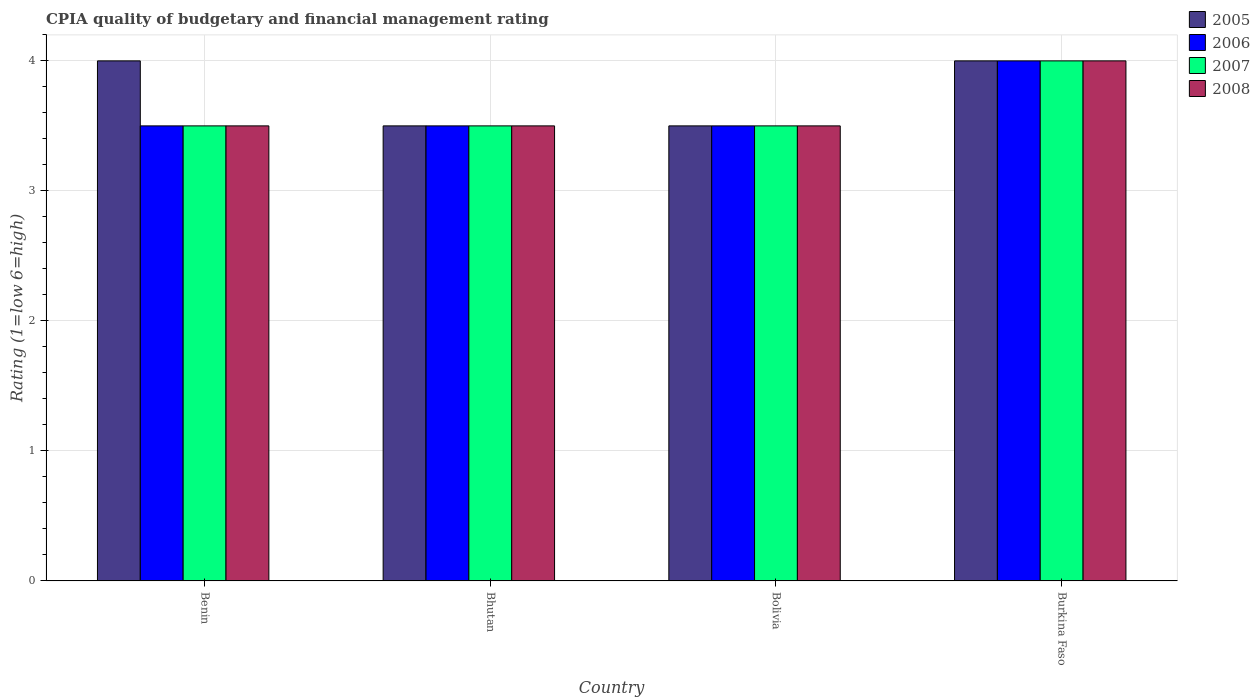How many groups of bars are there?
Offer a very short reply. 4. What is the label of the 2nd group of bars from the left?
Offer a terse response. Bhutan. What is the CPIA rating in 2005 in Bhutan?
Offer a very short reply. 3.5. Across all countries, what is the maximum CPIA rating in 2007?
Ensure brevity in your answer.  4. In which country was the CPIA rating in 2007 maximum?
Give a very brief answer. Burkina Faso. In which country was the CPIA rating in 2007 minimum?
Give a very brief answer. Benin. What is the difference between the CPIA rating in 2008 in Burkina Faso and the CPIA rating in 2005 in Bhutan?
Provide a succinct answer. 0.5. What is the average CPIA rating in 2006 per country?
Give a very brief answer. 3.62. What is the ratio of the CPIA rating in 2006 in Bolivia to that in Burkina Faso?
Your response must be concise. 0.88. Is the CPIA rating in 2007 in Bolivia less than that in Burkina Faso?
Keep it short and to the point. Yes. In how many countries, is the CPIA rating in 2007 greater than the average CPIA rating in 2007 taken over all countries?
Your answer should be compact. 1. What does the 3rd bar from the left in Benin represents?
Offer a terse response. 2007. Is it the case that in every country, the sum of the CPIA rating in 2007 and CPIA rating in 2008 is greater than the CPIA rating in 2005?
Provide a short and direct response. Yes. How many countries are there in the graph?
Make the answer very short. 4. What is the difference between two consecutive major ticks on the Y-axis?
Offer a very short reply. 1. Does the graph contain any zero values?
Your response must be concise. No. Where does the legend appear in the graph?
Ensure brevity in your answer.  Top right. How are the legend labels stacked?
Give a very brief answer. Vertical. What is the title of the graph?
Offer a terse response. CPIA quality of budgetary and financial management rating. What is the label or title of the Y-axis?
Your response must be concise. Rating (1=low 6=high). What is the Rating (1=low 6=high) of 2005 in Benin?
Provide a succinct answer. 4. What is the Rating (1=low 6=high) in 2007 in Benin?
Ensure brevity in your answer.  3.5. What is the Rating (1=low 6=high) in 2005 in Bhutan?
Provide a succinct answer. 3.5. What is the Rating (1=low 6=high) in 2006 in Bhutan?
Provide a succinct answer. 3.5. What is the Rating (1=low 6=high) of 2008 in Bhutan?
Provide a succinct answer. 3.5. What is the Rating (1=low 6=high) of 2005 in Bolivia?
Your answer should be compact. 3.5. What is the Rating (1=low 6=high) of 2006 in Bolivia?
Provide a succinct answer. 3.5. What is the Rating (1=low 6=high) of 2007 in Bolivia?
Provide a succinct answer. 3.5. What is the Rating (1=low 6=high) of 2008 in Bolivia?
Provide a short and direct response. 3.5. What is the Rating (1=low 6=high) of 2005 in Burkina Faso?
Give a very brief answer. 4. What is the Rating (1=low 6=high) in 2006 in Burkina Faso?
Your answer should be very brief. 4. What is the Rating (1=low 6=high) in 2007 in Burkina Faso?
Your answer should be compact. 4. Across all countries, what is the maximum Rating (1=low 6=high) in 2005?
Offer a very short reply. 4. Across all countries, what is the maximum Rating (1=low 6=high) in 2006?
Your answer should be very brief. 4. Across all countries, what is the minimum Rating (1=low 6=high) of 2006?
Offer a terse response. 3.5. Across all countries, what is the minimum Rating (1=low 6=high) of 2008?
Offer a very short reply. 3.5. What is the total Rating (1=low 6=high) of 2007 in the graph?
Your response must be concise. 14.5. What is the difference between the Rating (1=low 6=high) of 2005 in Benin and that in Bhutan?
Give a very brief answer. 0.5. What is the difference between the Rating (1=low 6=high) of 2006 in Benin and that in Bhutan?
Make the answer very short. 0. What is the difference between the Rating (1=low 6=high) of 2007 in Benin and that in Bhutan?
Your answer should be compact. 0. What is the difference between the Rating (1=low 6=high) of 2008 in Benin and that in Bhutan?
Provide a succinct answer. 0. What is the difference between the Rating (1=low 6=high) in 2005 in Benin and that in Bolivia?
Ensure brevity in your answer.  0.5. What is the difference between the Rating (1=low 6=high) in 2007 in Benin and that in Bolivia?
Give a very brief answer. 0. What is the difference between the Rating (1=low 6=high) of 2005 in Benin and that in Burkina Faso?
Offer a terse response. 0. What is the difference between the Rating (1=low 6=high) in 2007 in Benin and that in Burkina Faso?
Your answer should be compact. -0.5. What is the difference between the Rating (1=low 6=high) in 2006 in Bhutan and that in Bolivia?
Provide a short and direct response. 0. What is the difference between the Rating (1=low 6=high) in 2007 in Bhutan and that in Bolivia?
Keep it short and to the point. 0. What is the difference between the Rating (1=low 6=high) of 2007 in Bhutan and that in Burkina Faso?
Make the answer very short. -0.5. What is the difference between the Rating (1=low 6=high) of 2006 in Bolivia and that in Burkina Faso?
Give a very brief answer. -0.5. What is the difference between the Rating (1=low 6=high) of 2005 in Benin and the Rating (1=low 6=high) of 2006 in Bhutan?
Give a very brief answer. 0.5. What is the difference between the Rating (1=low 6=high) in 2005 in Benin and the Rating (1=low 6=high) in 2007 in Bhutan?
Your response must be concise. 0.5. What is the difference between the Rating (1=low 6=high) of 2005 in Benin and the Rating (1=low 6=high) of 2008 in Bhutan?
Make the answer very short. 0.5. What is the difference between the Rating (1=low 6=high) of 2006 in Benin and the Rating (1=low 6=high) of 2007 in Bhutan?
Provide a short and direct response. 0. What is the difference between the Rating (1=low 6=high) in 2005 in Benin and the Rating (1=low 6=high) in 2008 in Bolivia?
Keep it short and to the point. 0.5. What is the difference between the Rating (1=low 6=high) in 2006 in Benin and the Rating (1=low 6=high) in 2008 in Bolivia?
Provide a succinct answer. 0. What is the difference between the Rating (1=low 6=high) of 2007 in Benin and the Rating (1=low 6=high) of 2008 in Bolivia?
Provide a short and direct response. 0. What is the difference between the Rating (1=low 6=high) of 2005 in Benin and the Rating (1=low 6=high) of 2006 in Burkina Faso?
Offer a terse response. 0. What is the difference between the Rating (1=low 6=high) of 2005 in Benin and the Rating (1=low 6=high) of 2007 in Burkina Faso?
Make the answer very short. 0. What is the difference between the Rating (1=low 6=high) of 2005 in Benin and the Rating (1=low 6=high) of 2008 in Burkina Faso?
Your response must be concise. 0. What is the difference between the Rating (1=low 6=high) in 2006 in Benin and the Rating (1=low 6=high) in 2007 in Burkina Faso?
Provide a succinct answer. -0.5. What is the difference between the Rating (1=low 6=high) in 2006 in Benin and the Rating (1=low 6=high) in 2008 in Burkina Faso?
Provide a short and direct response. -0.5. What is the difference between the Rating (1=low 6=high) in 2007 in Benin and the Rating (1=low 6=high) in 2008 in Burkina Faso?
Provide a short and direct response. -0.5. What is the difference between the Rating (1=low 6=high) in 2005 in Bhutan and the Rating (1=low 6=high) in 2007 in Bolivia?
Offer a very short reply. 0. What is the difference between the Rating (1=low 6=high) in 2006 in Bhutan and the Rating (1=low 6=high) in 2007 in Bolivia?
Your answer should be compact. 0. What is the difference between the Rating (1=low 6=high) in 2006 in Bhutan and the Rating (1=low 6=high) in 2008 in Bolivia?
Your answer should be very brief. 0. What is the difference between the Rating (1=low 6=high) of 2007 in Bhutan and the Rating (1=low 6=high) of 2008 in Bolivia?
Make the answer very short. 0. What is the difference between the Rating (1=low 6=high) of 2005 in Bhutan and the Rating (1=low 6=high) of 2006 in Burkina Faso?
Your answer should be very brief. -0.5. What is the difference between the Rating (1=low 6=high) in 2005 in Bhutan and the Rating (1=low 6=high) in 2007 in Burkina Faso?
Ensure brevity in your answer.  -0.5. What is the difference between the Rating (1=low 6=high) of 2006 in Bhutan and the Rating (1=low 6=high) of 2007 in Burkina Faso?
Keep it short and to the point. -0.5. What is the difference between the Rating (1=low 6=high) of 2005 in Bolivia and the Rating (1=low 6=high) of 2006 in Burkina Faso?
Keep it short and to the point. -0.5. What is the difference between the Rating (1=low 6=high) in 2005 in Bolivia and the Rating (1=low 6=high) in 2008 in Burkina Faso?
Ensure brevity in your answer.  -0.5. What is the difference between the Rating (1=low 6=high) of 2006 in Bolivia and the Rating (1=low 6=high) of 2008 in Burkina Faso?
Offer a very short reply. -0.5. What is the average Rating (1=low 6=high) in 2005 per country?
Offer a terse response. 3.75. What is the average Rating (1=low 6=high) of 2006 per country?
Your answer should be very brief. 3.62. What is the average Rating (1=low 6=high) of 2007 per country?
Your answer should be very brief. 3.62. What is the average Rating (1=low 6=high) in 2008 per country?
Your response must be concise. 3.62. What is the difference between the Rating (1=low 6=high) in 2006 and Rating (1=low 6=high) in 2008 in Benin?
Offer a terse response. 0. What is the difference between the Rating (1=low 6=high) in 2005 and Rating (1=low 6=high) in 2006 in Bhutan?
Provide a succinct answer. 0. What is the difference between the Rating (1=low 6=high) of 2005 and Rating (1=low 6=high) of 2007 in Bhutan?
Ensure brevity in your answer.  0. What is the difference between the Rating (1=low 6=high) of 2006 and Rating (1=low 6=high) of 2007 in Bhutan?
Give a very brief answer. 0. What is the difference between the Rating (1=low 6=high) in 2007 and Rating (1=low 6=high) in 2008 in Bhutan?
Offer a terse response. 0. What is the difference between the Rating (1=low 6=high) in 2005 and Rating (1=low 6=high) in 2006 in Bolivia?
Provide a succinct answer. 0. What is the difference between the Rating (1=low 6=high) in 2005 and Rating (1=low 6=high) in 2007 in Bolivia?
Give a very brief answer. 0. What is the difference between the Rating (1=low 6=high) of 2006 and Rating (1=low 6=high) of 2008 in Bolivia?
Give a very brief answer. 0. What is the difference between the Rating (1=low 6=high) of 2005 and Rating (1=low 6=high) of 2007 in Burkina Faso?
Ensure brevity in your answer.  0. What is the ratio of the Rating (1=low 6=high) in 2006 in Benin to that in Bhutan?
Offer a terse response. 1. What is the ratio of the Rating (1=low 6=high) in 2005 in Benin to that in Bolivia?
Keep it short and to the point. 1.14. What is the ratio of the Rating (1=low 6=high) in 2006 in Benin to that in Bolivia?
Your answer should be very brief. 1. What is the ratio of the Rating (1=low 6=high) of 2008 in Benin to that in Bolivia?
Ensure brevity in your answer.  1. What is the ratio of the Rating (1=low 6=high) in 2006 in Benin to that in Burkina Faso?
Make the answer very short. 0.88. What is the ratio of the Rating (1=low 6=high) in 2008 in Benin to that in Burkina Faso?
Provide a short and direct response. 0.88. What is the ratio of the Rating (1=low 6=high) in 2005 in Bhutan to that in Bolivia?
Your response must be concise. 1. What is the ratio of the Rating (1=low 6=high) of 2006 in Bhutan to that in Bolivia?
Offer a very short reply. 1. What is the ratio of the Rating (1=low 6=high) of 2008 in Bhutan to that in Bolivia?
Ensure brevity in your answer.  1. What is the ratio of the Rating (1=low 6=high) of 2005 in Bhutan to that in Burkina Faso?
Offer a terse response. 0.88. What is the ratio of the Rating (1=low 6=high) in 2006 in Bhutan to that in Burkina Faso?
Provide a succinct answer. 0.88. What is the ratio of the Rating (1=low 6=high) in 2007 in Bhutan to that in Burkina Faso?
Make the answer very short. 0.88. What is the ratio of the Rating (1=low 6=high) in 2005 in Bolivia to that in Burkina Faso?
Provide a short and direct response. 0.88. What is the ratio of the Rating (1=low 6=high) of 2006 in Bolivia to that in Burkina Faso?
Offer a terse response. 0.88. What is the ratio of the Rating (1=low 6=high) in 2007 in Bolivia to that in Burkina Faso?
Provide a short and direct response. 0.88. What is the difference between the highest and the second highest Rating (1=low 6=high) of 2006?
Your answer should be very brief. 0.5. What is the difference between the highest and the lowest Rating (1=low 6=high) in 2005?
Provide a short and direct response. 0.5. 